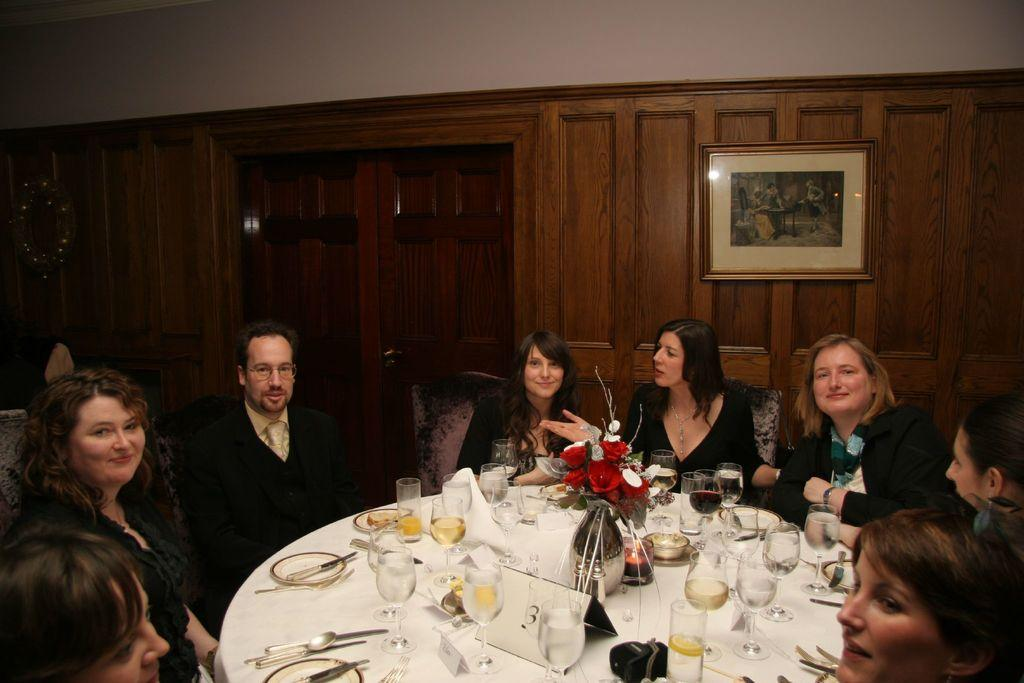What is happening in the image? There is a group of people in the image, and they are sitting around a table. What activity are the people engaged in? The people are having their dinner. What type of tent can be seen in the background of the image? There is no tent present in the image; it features a group of people sitting around a table having dinner. 